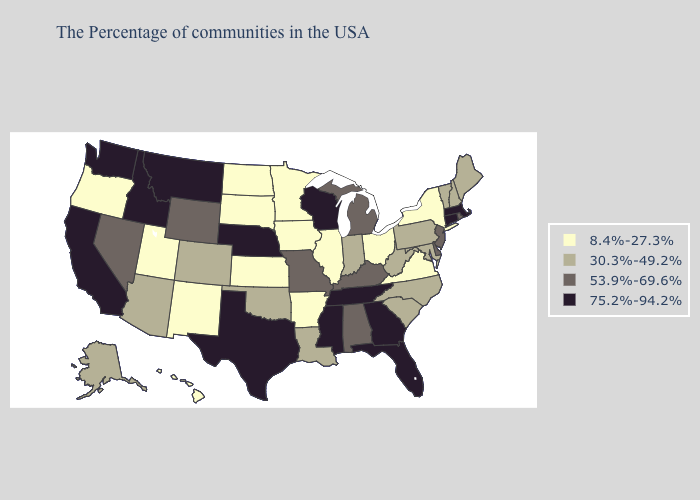Does Pennsylvania have the lowest value in the Northeast?
Concise answer only. No. Which states have the lowest value in the Northeast?
Give a very brief answer. New York. Name the states that have a value in the range 8.4%-27.3%?
Write a very short answer. New York, Virginia, Ohio, Illinois, Arkansas, Minnesota, Iowa, Kansas, South Dakota, North Dakota, New Mexico, Utah, Oregon, Hawaii. Name the states that have a value in the range 8.4%-27.3%?
Write a very short answer. New York, Virginia, Ohio, Illinois, Arkansas, Minnesota, Iowa, Kansas, South Dakota, North Dakota, New Mexico, Utah, Oregon, Hawaii. What is the highest value in the South ?
Give a very brief answer. 75.2%-94.2%. What is the highest value in the West ?
Keep it brief. 75.2%-94.2%. What is the value of Missouri?
Short answer required. 53.9%-69.6%. Name the states that have a value in the range 30.3%-49.2%?
Write a very short answer. Maine, New Hampshire, Vermont, Maryland, Pennsylvania, North Carolina, South Carolina, West Virginia, Indiana, Louisiana, Oklahoma, Colorado, Arizona, Alaska. Does the map have missing data?
Write a very short answer. No. What is the lowest value in the USA?
Give a very brief answer. 8.4%-27.3%. Is the legend a continuous bar?
Short answer required. No. Which states have the highest value in the USA?
Give a very brief answer. Massachusetts, Connecticut, Florida, Georgia, Tennessee, Wisconsin, Mississippi, Nebraska, Texas, Montana, Idaho, California, Washington. Name the states that have a value in the range 8.4%-27.3%?
Answer briefly. New York, Virginia, Ohio, Illinois, Arkansas, Minnesota, Iowa, Kansas, South Dakota, North Dakota, New Mexico, Utah, Oregon, Hawaii. Which states have the highest value in the USA?
Answer briefly. Massachusetts, Connecticut, Florida, Georgia, Tennessee, Wisconsin, Mississippi, Nebraska, Texas, Montana, Idaho, California, Washington. Among the states that border Pennsylvania , which have the highest value?
Concise answer only. New Jersey, Delaware. 